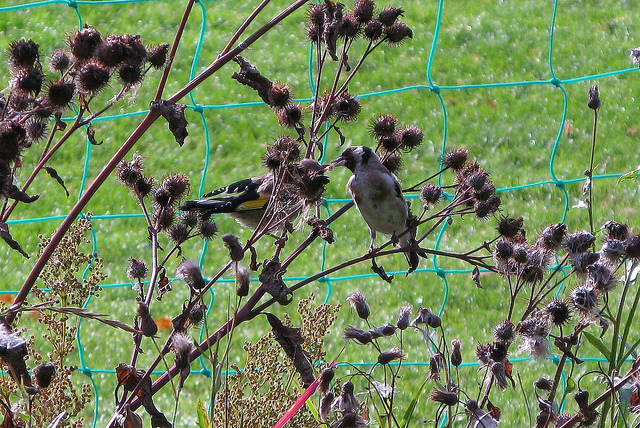What kind of birds are visible in this image? The image shows two birds; the one with bright yellow and black plumage is likely an American Goldfinch. The other bird, with a less distinct pattern and lighter coloration, might be a juvenile or a female of the same species or a different one that isn't as easily identifiable from this angle. 